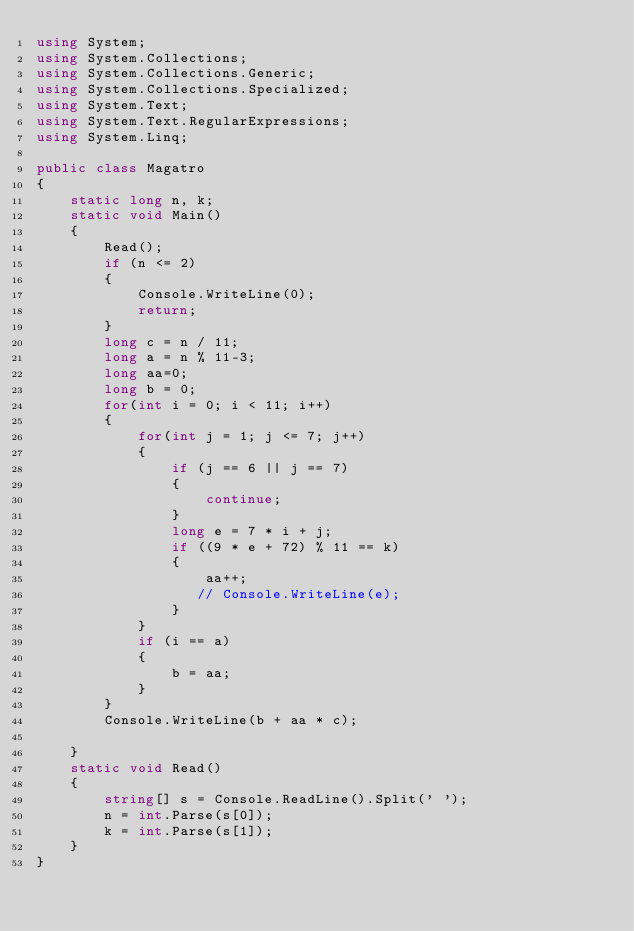<code> <loc_0><loc_0><loc_500><loc_500><_C#_>using System;
using System.Collections;
using System.Collections.Generic;
using System.Collections.Specialized;
using System.Text;
using System.Text.RegularExpressions;
using System.Linq;

public class Magatro
{
    static long n, k;
    static void Main()
    {
        Read();
        if (n <= 2)
        {
            Console.WriteLine(0);
            return;
        }
        long c = n / 11;
        long a = n % 11-3;
        long aa=0;
        long b = 0;
        for(int i = 0; i < 11; i++)
        {
            for(int j = 1; j <= 7; j++)
            {
                if (j == 6 || j == 7)
                {
                    continue;
                }
                long e = 7 * i + j;
                if ((9 * e + 72) % 11 == k)
                {
                    aa++;
                   // Console.WriteLine(e);
                }
            }
            if (i == a)
            {
                b = aa;
            }
        }
        Console.WriteLine(b + aa * c);

    }
    static void Read()
    {
        string[] s = Console.ReadLine().Split(' ');
        n = int.Parse(s[0]);
        k = int.Parse(s[1]);
    }
}


</code> 